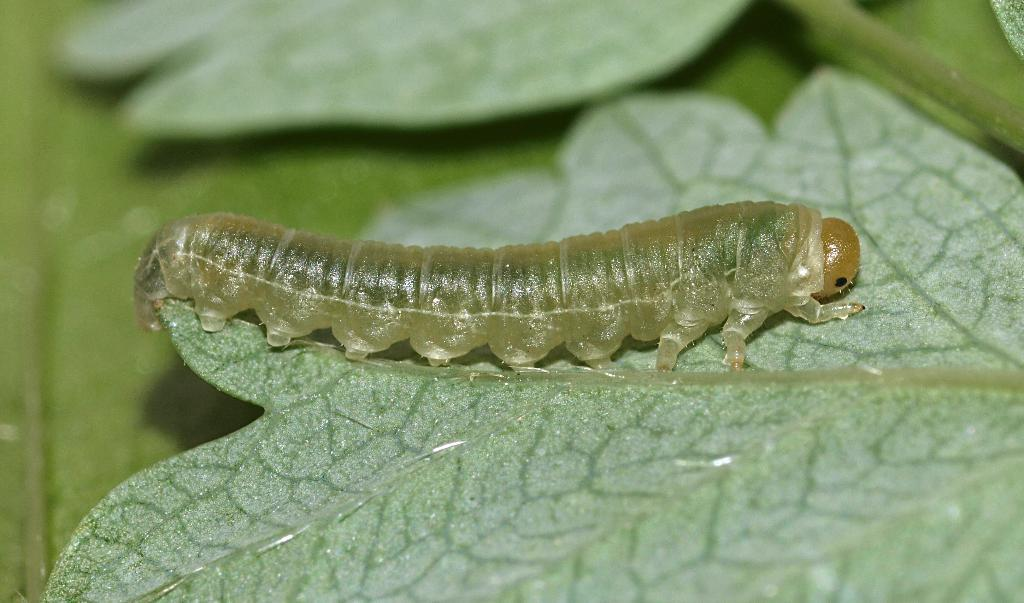What type of creature is present in the image? There is an insect in the image. Where is the insect located? The insect is on a leaf. Can you describe the background of the image? The background of the image is blurred. What type of office furniture can be seen in the image? There is no office furniture present in the image; it features an insect on a leaf with a blurred background. What type of rat is visible in the image? There is no rat present in the image. How does the insect use the umbrella in the image? There is no umbrella present in the image; it features an insect on a leaf with a blurred background. 